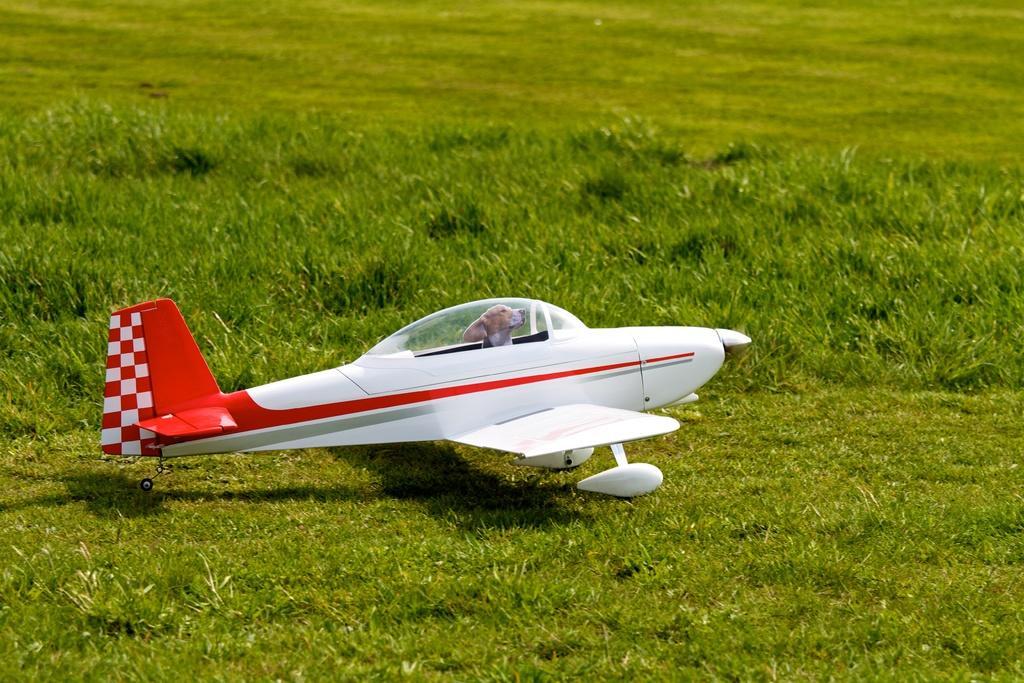Describe this image in one or two sentences. In this picture we can see an aircraft on the grass. There is a dog in this aircraft. 